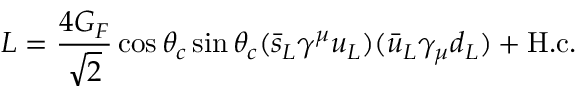Convert formula to latex. <formula><loc_0><loc_0><loc_500><loc_500>L = { \frac { 4 G _ { F } } { \sqrt { 2 } } } \cos \theta _ { c } \sin \theta _ { c } ( \bar { s } _ { L } \gamma ^ { \mu } u _ { L } ) ( \bar { u } _ { L } \gamma _ { \mu } d _ { L } ) + H . c .</formula> 